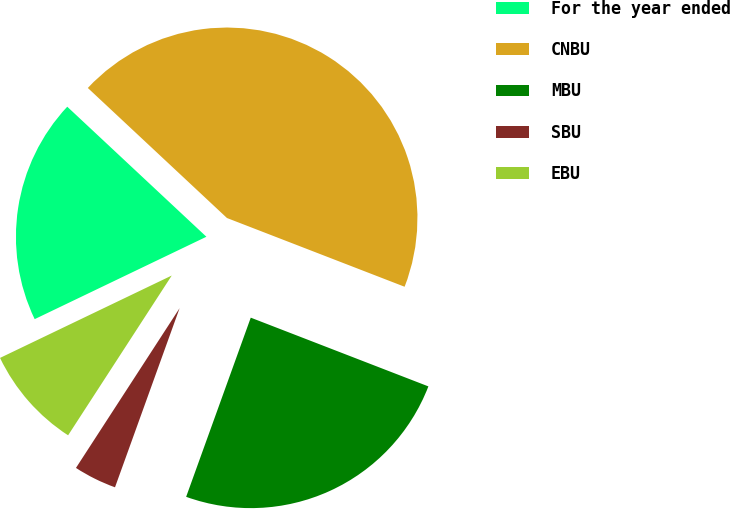<chart> <loc_0><loc_0><loc_500><loc_500><pie_chart><fcel>For the year ended<fcel>CNBU<fcel>MBU<fcel>SBU<fcel>EBU<nl><fcel>19.08%<fcel>43.91%<fcel>24.63%<fcel>3.65%<fcel>8.72%<nl></chart> 